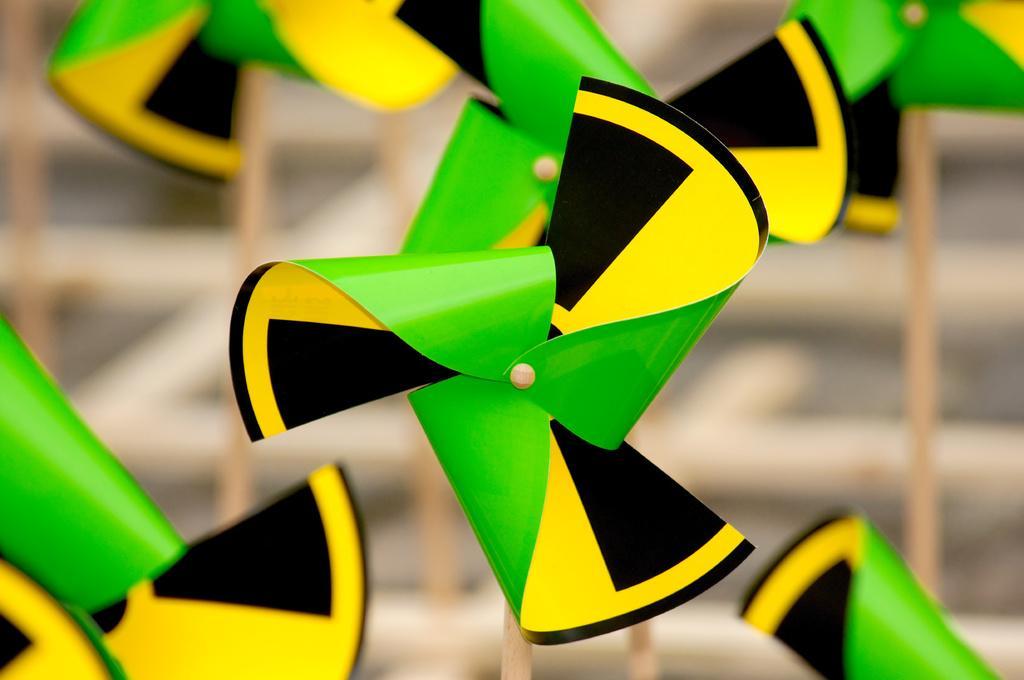Describe this image in one or two sentences. In this image we can see the yellow, green and black color pinwheel. The background of the image is blurred, where we can see a few more pinwheels. 